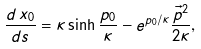<formula> <loc_0><loc_0><loc_500><loc_500>\frac { d \, x _ { 0 } } { d s } = \kappa \sinh \frac { p _ { 0 } } \kappa - e ^ { p _ { 0 } / \kappa } \frac { \vec { p } ^ { 2 } } { 2 \kappa } ,</formula> 